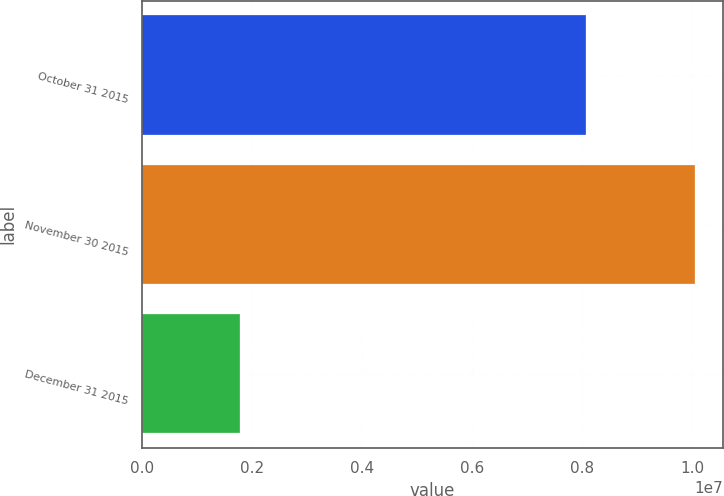<chart> <loc_0><loc_0><loc_500><loc_500><bar_chart><fcel>October 31 2015<fcel>November 30 2015<fcel>December 31 2015<nl><fcel>8.06182e+06<fcel>1.00513e+07<fcel>1.78489e+06<nl></chart> 